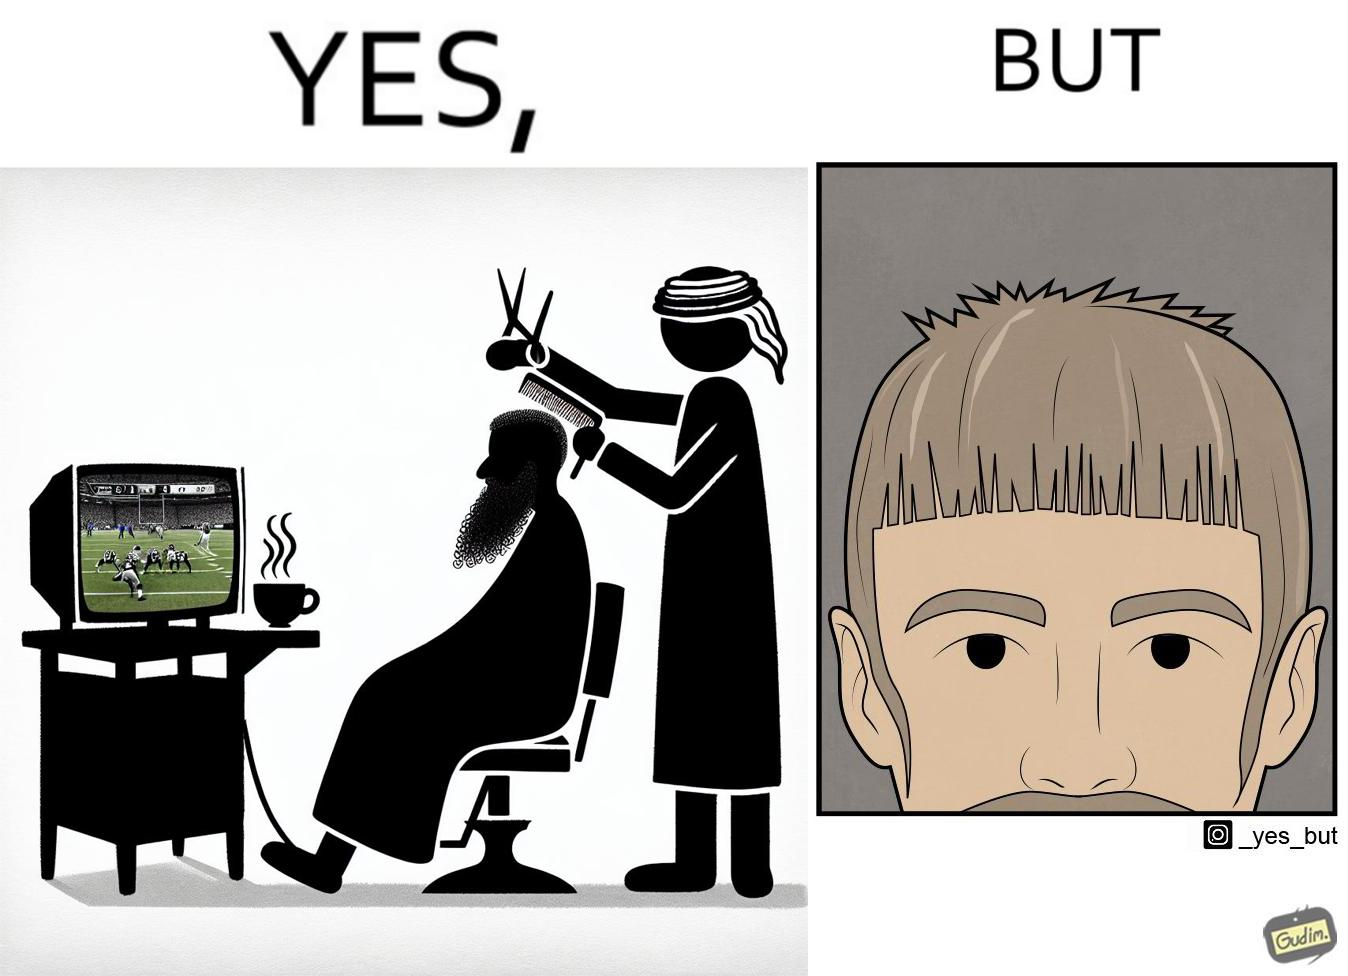Describe the contrast between the left and right parts of this image. In the left part of the image: a person at a men's saloon during his hair cut, playing football game on tv and a person serving him some beverage in cup In the right part of the image: a person with an average looking haircut 